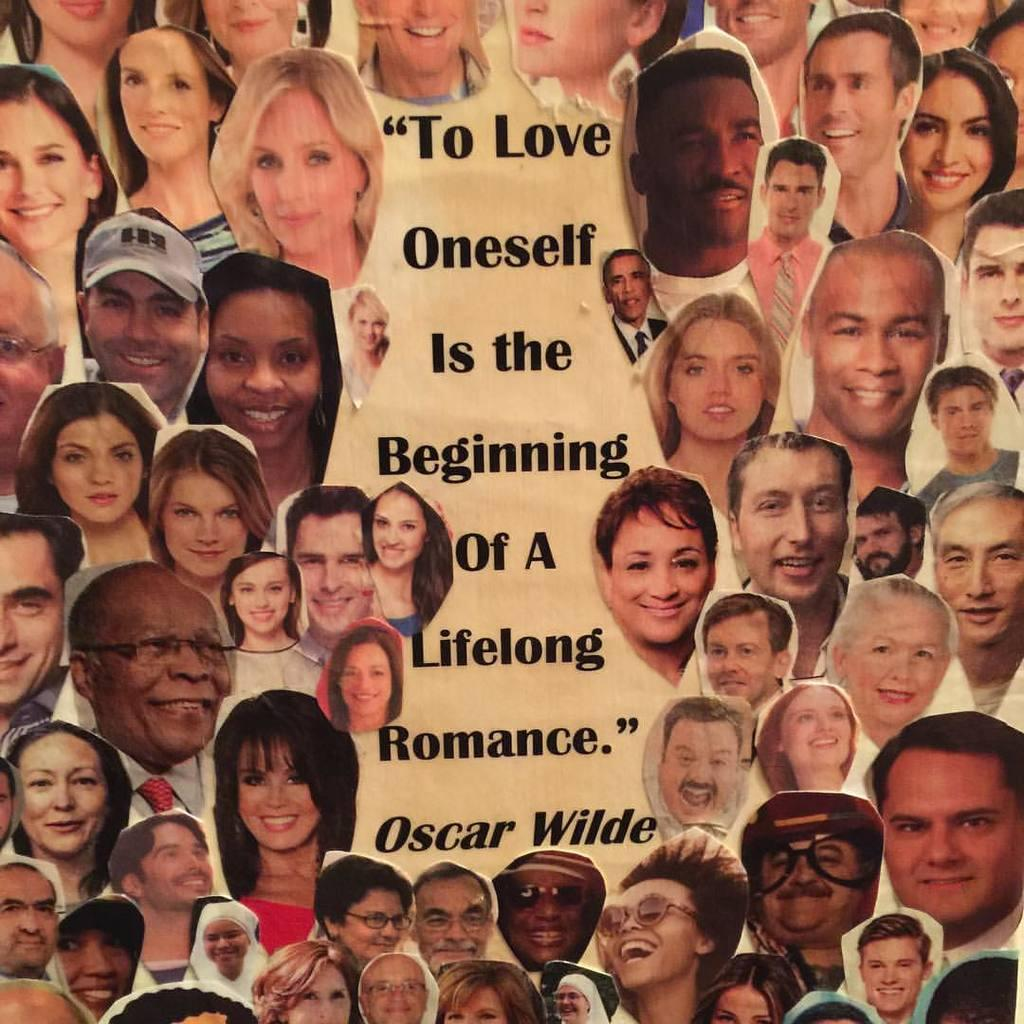What type of visual is the image? The image is a poster. What can be seen in the poster? There is a group of people in the image. Are there any words or phrases on the poster? Yes, there is text on the poster. What type of vest is the worm wearing in the image? There is no worm or vest present in the image. How is the lace used in the image? There is no lace present in the image. 